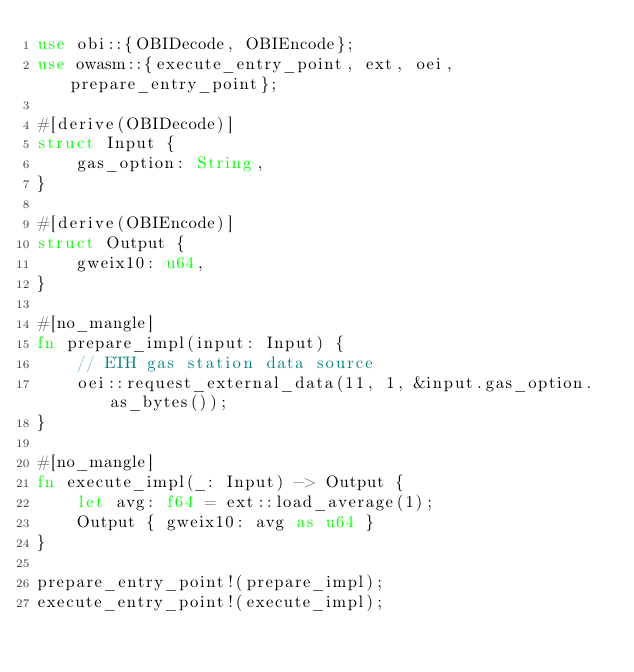<code> <loc_0><loc_0><loc_500><loc_500><_Rust_>use obi::{OBIDecode, OBIEncode};
use owasm::{execute_entry_point, ext, oei, prepare_entry_point};

#[derive(OBIDecode)]
struct Input {
    gas_option: String,
}

#[derive(OBIEncode)]
struct Output {
    gweix10: u64,
}

#[no_mangle]
fn prepare_impl(input: Input) {
    // ETH gas station data source
    oei::request_external_data(11, 1, &input.gas_option.as_bytes());
}

#[no_mangle]
fn execute_impl(_: Input) -> Output {
    let avg: f64 = ext::load_average(1);
    Output { gweix10: avg as u64 }
}

prepare_entry_point!(prepare_impl);
execute_entry_point!(execute_impl);
</code> 